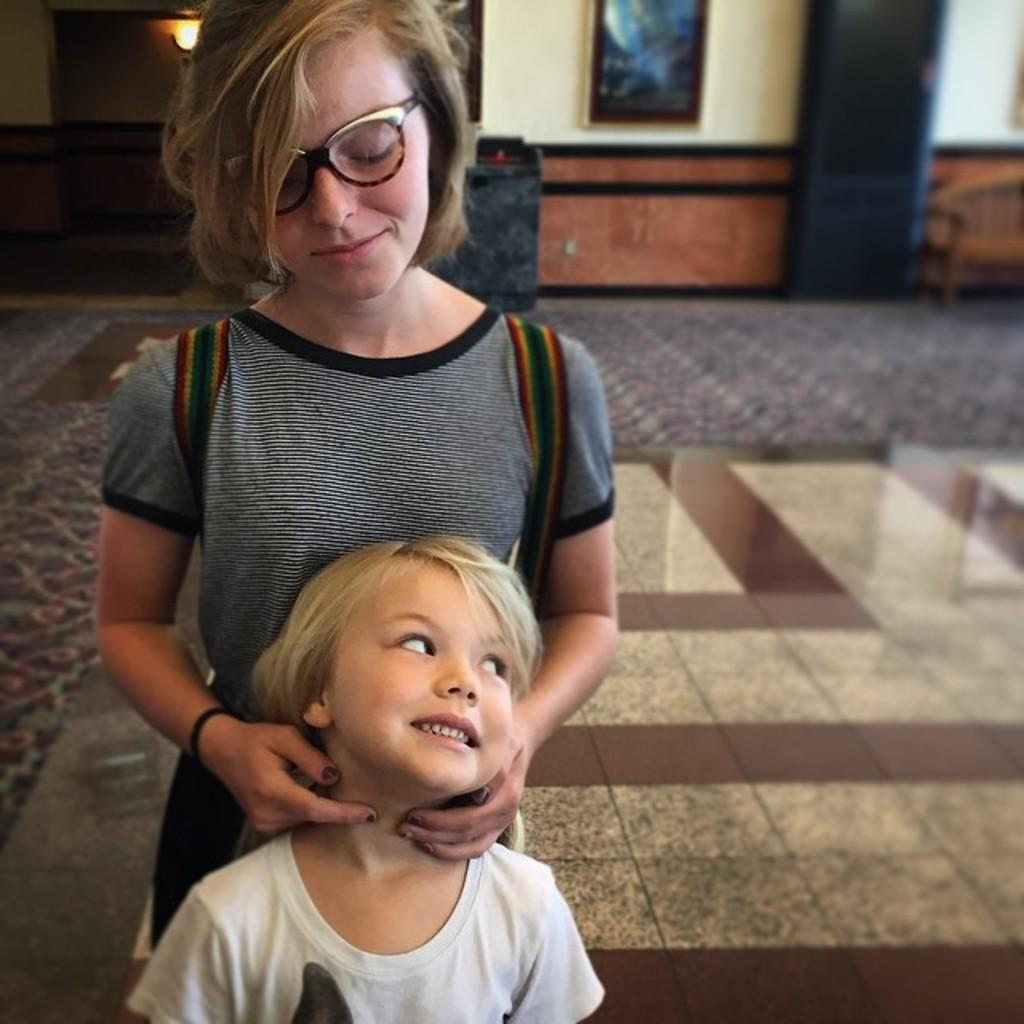Who is present in the image? There is a person and a kid in the image. What are the person and the kid wearing? Both the person and the kid are wearing clothes. What can be seen on the wall in the image? There is a photo frame on the wall in the image. Where is the light source located in the image? There is a light in the top left of the image. How many bikes are being ridden by the person and the kid in the image? There are no bikes present in the image. What type of control does the person have over the tree in the image? There is no tree present in the image, and therefore no control can be exercised over it. 